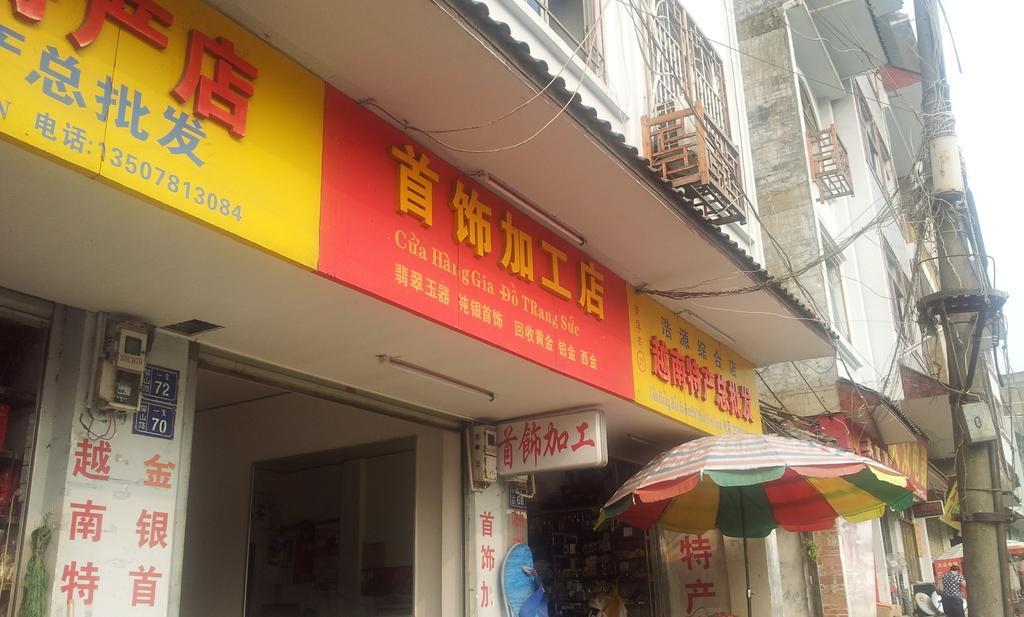Please provide a concise description of this image. As we can see in the image there are buildings, windows, banners, current pole, an umbrella, a person standing on the right side and there is sky. 